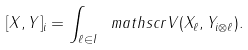Convert formula to latex. <formula><loc_0><loc_0><loc_500><loc_500>[ X , Y ] _ { i } = \int _ { \ell \in I } \ m a t h s c r { V } ( X _ { \ell } , Y _ { i \otimes \ell } ) .</formula> 